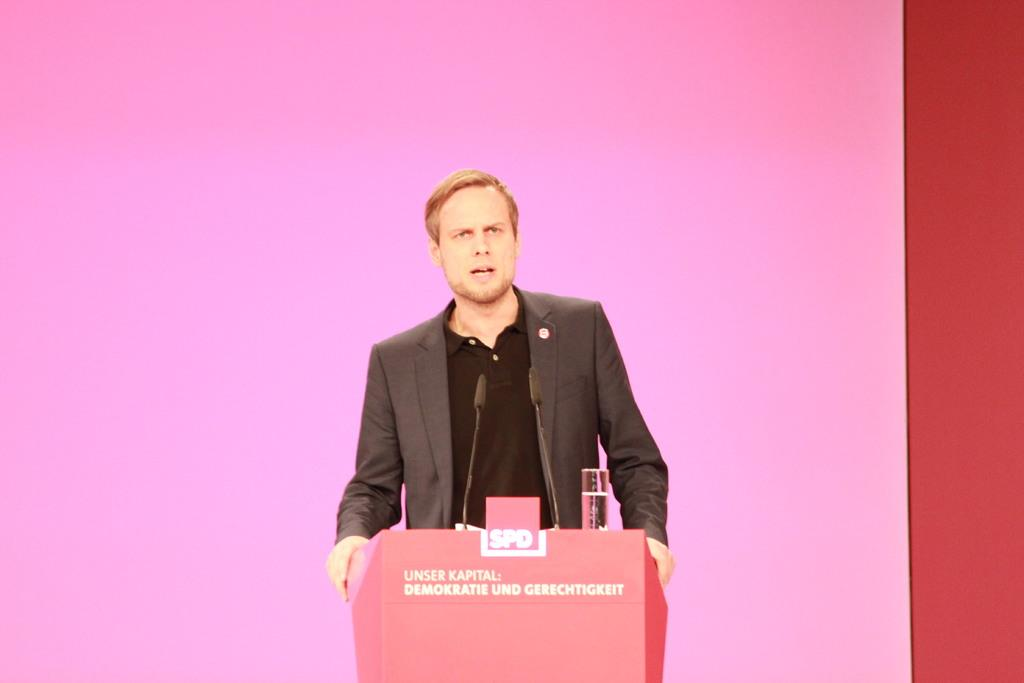Who or what is present in the image? There is a person in the image. What color is the background of the image? The background of the image is pink. What object can be seen at the bottom of the image? There is a podium at the bottom of the image. What time of day is it in the image? The time of day cannot be determined from the image, as there is no indication of the time. 